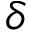<formula> <loc_0><loc_0><loc_500><loc_500>\boldsymbol \delta</formula> 